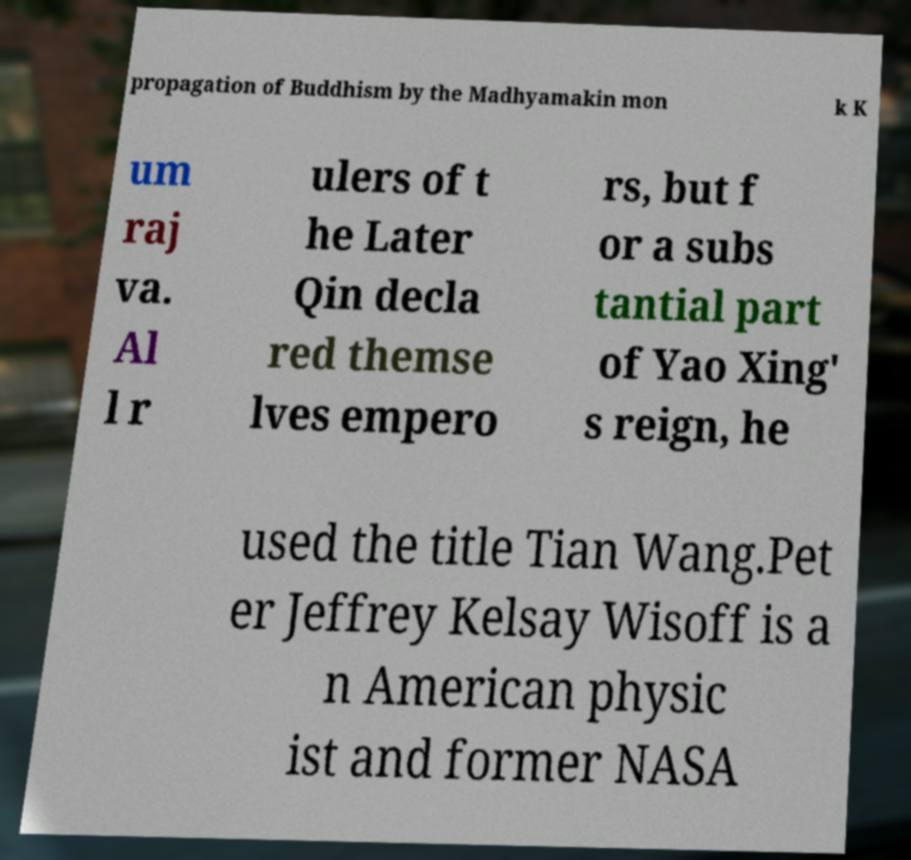Can you read and provide the text displayed in the image?This photo seems to have some interesting text. Can you extract and type it out for me? propagation of Buddhism by the Madhyamakin mon k K um raj va. Al l r ulers of t he Later Qin decla red themse lves empero rs, but f or a subs tantial part of Yao Xing' s reign, he used the title Tian Wang.Pet er Jeffrey Kelsay Wisoff is a n American physic ist and former NASA 